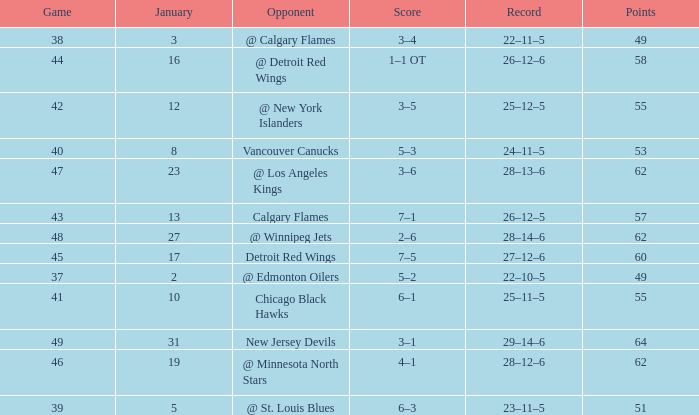Which Points have a Score of 4–1? 62.0. 